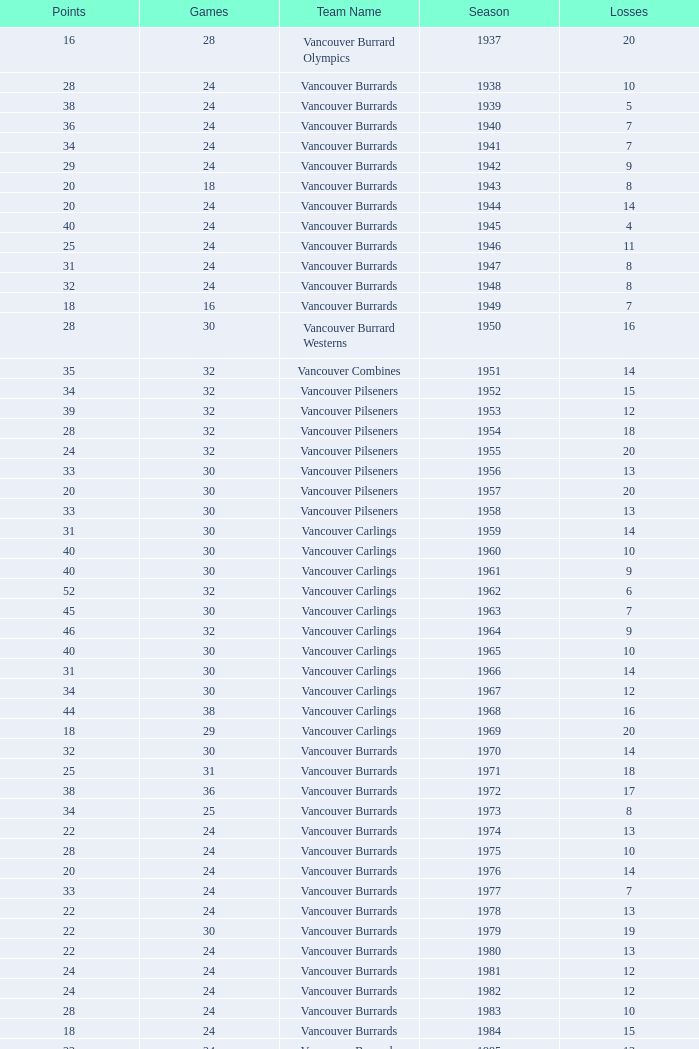What's the total number of points when the vancouver burrards have fewer than 9 losses and more than 24 games? 1.0. 